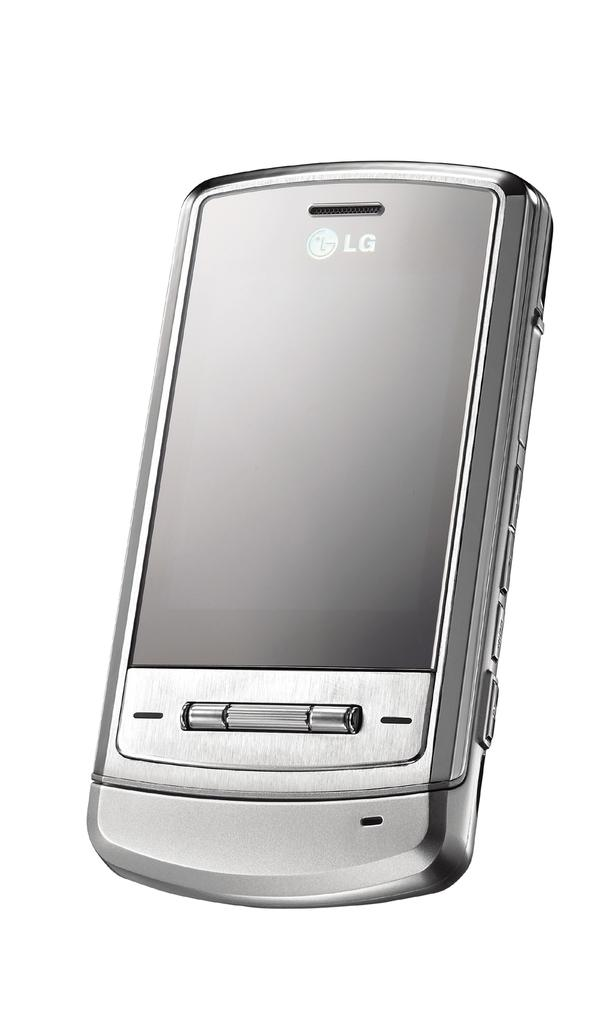<image>
Offer a succinct explanation of the picture presented. an LG logo that is on a phone 